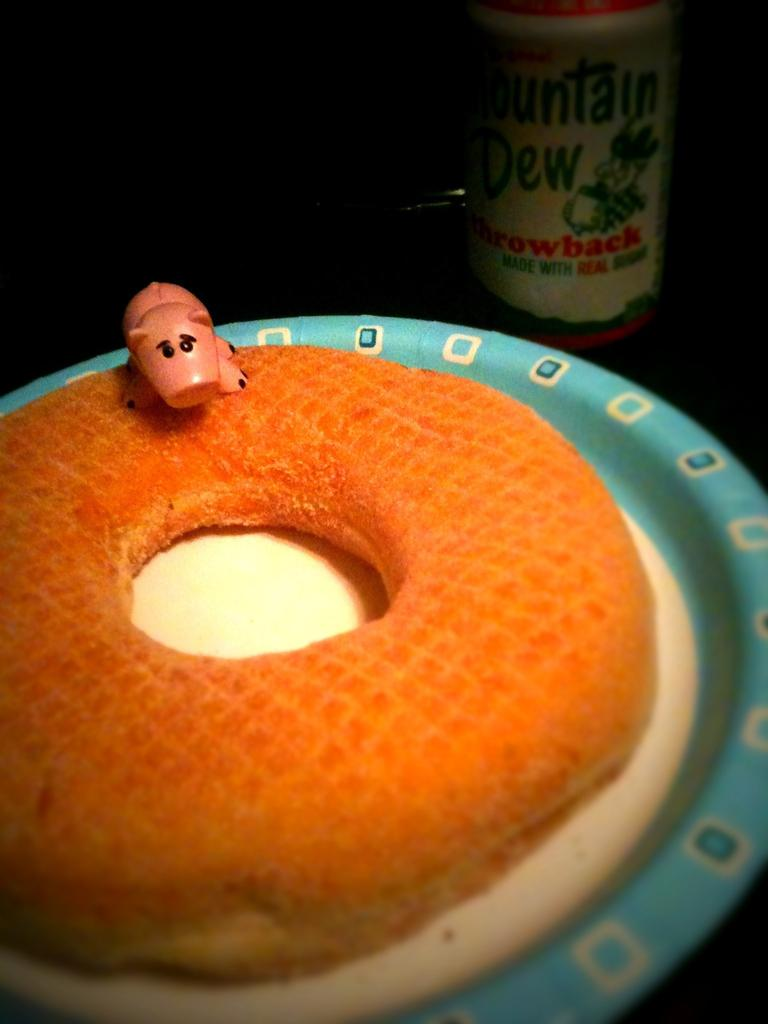What type of food is visible in the image? There is a doughnut in the image. Where is the doughnut located? The doughnut is on a plate. What else can be seen in the background of the image? There is a bottle in the background of the image. How many spiders are crawling on the doughnut in the image? There are no spiders visible in the image; it only features a doughnut on a plate and a bottle in the background. 